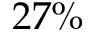Convert formula to latex. <formula><loc_0><loc_0><loc_500><loc_500>2 7 \%</formula> 